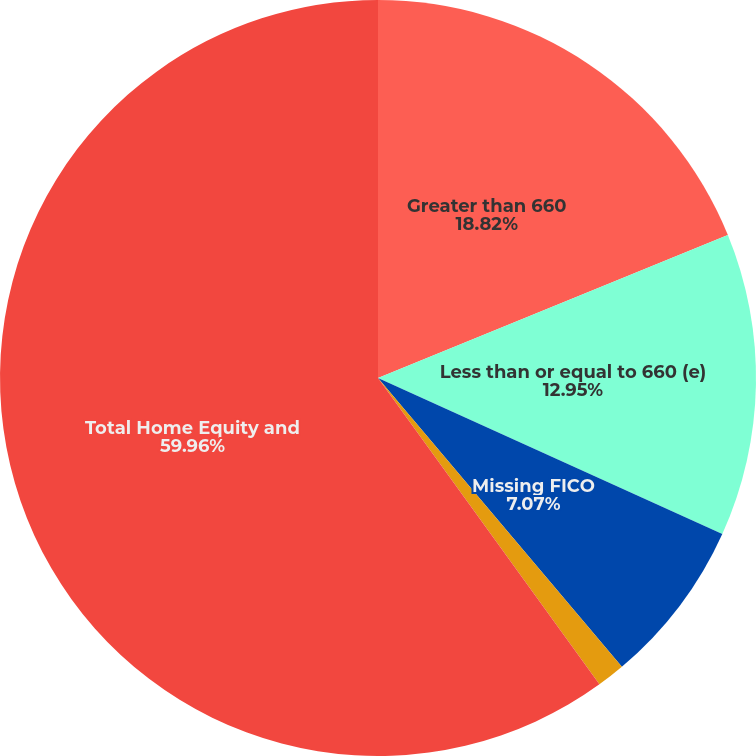Convert chart. <chart><loc_0><loc_0><loc_500><loc_500><pie_chart><fcel>Greater than 660<fcel>Less than or equal to 660 (e)<fcel>Missing FICO<fcel>Less than or equal to 660<fcel>Total Home Equity and<nl><fcel>18.82%<fcel>12.95%<fcel>7.07%<fcel>1.2%<fcel>59.96%<nl></chart> 